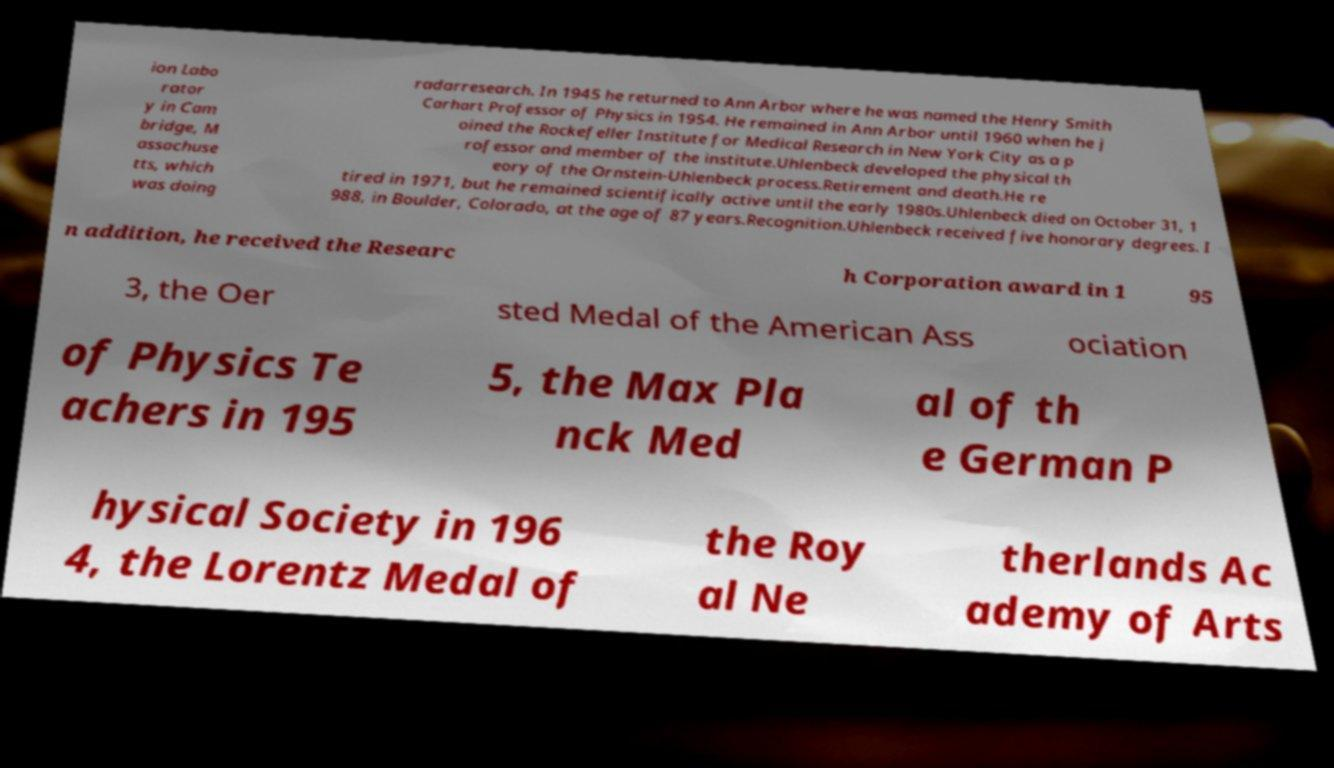Could you extract and type out the text from this image? ion Labo rator y in Cam bridge, M assachuse tts, which was doing radarresearch. In 1945 he returned to Ann Arbor where he was named the Henry Smith Carhart Professor of Physics in 1954. He remained in Ann Arbor until 1960 when he j oined the Rockefeller Institute for Medical Research in New York City as a p rofessor and member of the institute.Uhlenbeck developed the physical th eory of the Ornstein-Uhlenbeck process.Retirement and death.He re tired in 1971, but he remained scientifically active until the early 1980s.Uhlenbeck died on October 31, 1 988, in Boulder, Colorado, at the age of 87 years.Recognition.Uhlenbeck received five honorary degrees. I n addition, he received the Researc h Corporation award in 1 95 3, the Oer sted Medal of the American Ass ociation of Physics Te achers in 195 5, the Max Pla nck Med al of th e German P hysical Society in 196 4, the Lorentz Medal of the Roy al Ne therlands Ac ademy of Arts 